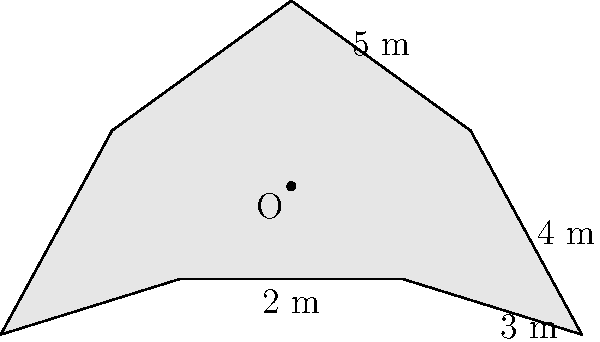In your church, a star-shaped chandelier casts a projection on the floor as shown in the diagram. The star has 8 identical triangular sections. Given that OA = 5 m, AB = 4 m, BC = 3 m, and CD = 2 m, calculate the area of the star-shaped projection. Round your answer to the nearest square meter. Let's approach this step-by-step:

1) The star consists of 8 congruent triangles. If we can find the area of one triangle and multiply it by 8, we'll have the total area.

2) Each triangle can be divided into three smaller triangles: OAB, OBC, and OCD.

3) For triangle OAB:
   Base = 4 m, Height = 5 m
   Area of OAB = $\frac{1}{2} \times 4 \times 5 = 10$ sq m

4) For triangle OBC:
   We need to find the height using the Pythagorean theorem:
   $h^2 + 4^2 = 5^2$
   $h^2 = 25 - 16 = 9$
   $h = 3$ m
   Area of OBC = $\frac{1}{2} \times 3 \times 3 = 4.5$ sq m

5) For triangle OCD:
   Base = 2 m, Height = 3 m
   Area of OCD = $\frac{1}{2} \times 2 \times 3 = 3$ sq m

6) Total area of one large triangle = 10 + 4.5 + 3 = 17.5 sq m

7) Area of the entire star = $8 \times 17.5 = 140$ sq m

Rounding to the nearest square meter, we get 140 sq m.
Answer: 140 sq m 